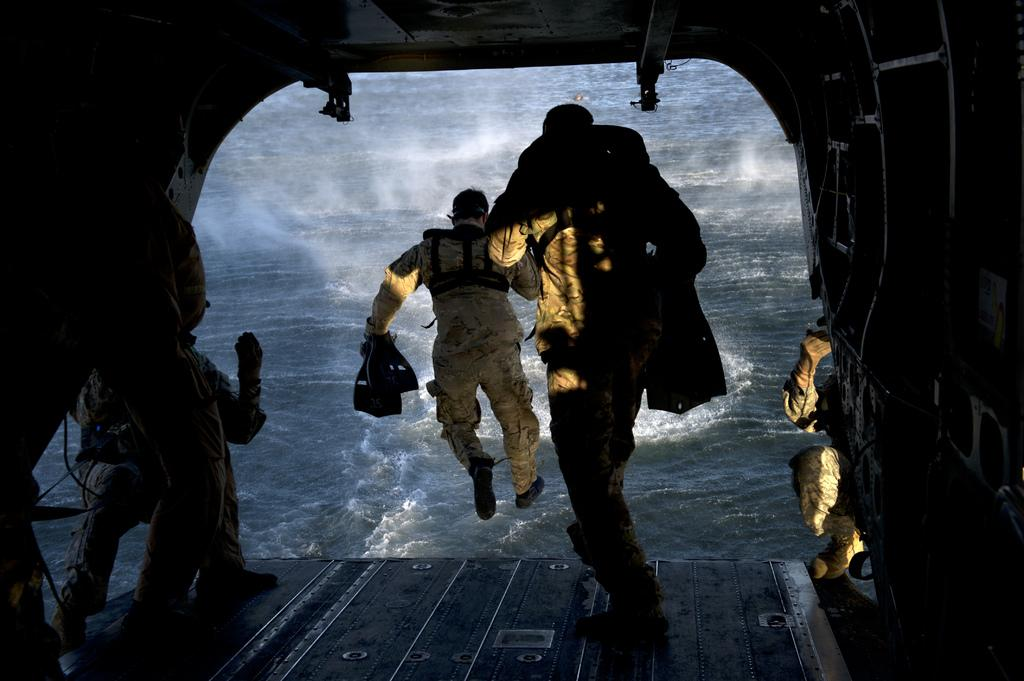How many people are in the image? There are people in the image, but the exact number is not specified. What is visible in the image besides the people? There is water, a roof, and walls visible in the image. What might the people be doing in the image? The people are holding objects, which suggests they might be engaged in some activity. What type of heat source can be seen in the image? There is no heat source visible in the image. What type of range or cooking appliance can be seen in the image? There is no range or cooking appliance visible in the image. 